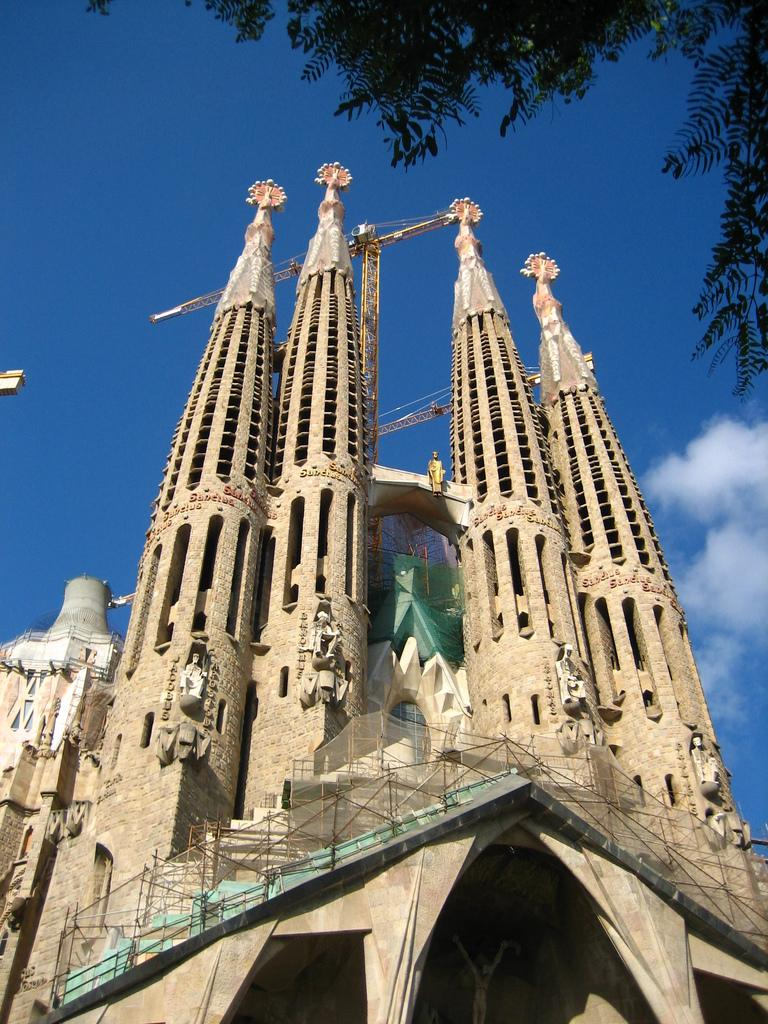What type of structures are present in the image? There are building towers in the image. Are there any decorative elements on the building towers? Yes, there are sculptures on the building. What additional feature can be seen in the image? There is a bridge in the image. What else is visible in the image besides the structures and bridge? There are other objects in the image. What can be seen in the background of the image? The sky is visible in the background of the image. How many geese are flying over the bridge in the image? There are no geese present in the image; it only features building towers, sculptures, a bridge, and other objects. 